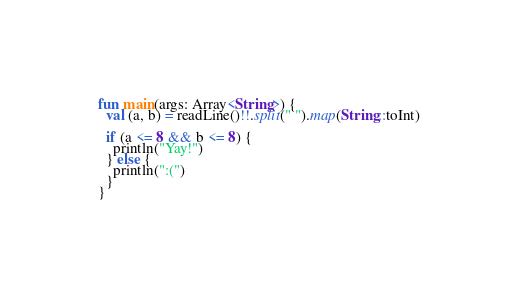Convert code to text. <code><loc_0><loc_0><loc_500><loc_500><_Kotlin_>fun main(args: Array<String>) {
  val (a, b) = readLine()!!.split(" ").map(String::toInt)

  if (a <= 8 && b <= 8) {
    println("Yay!")
  } else {
    println(":(")
  }
}</code> 